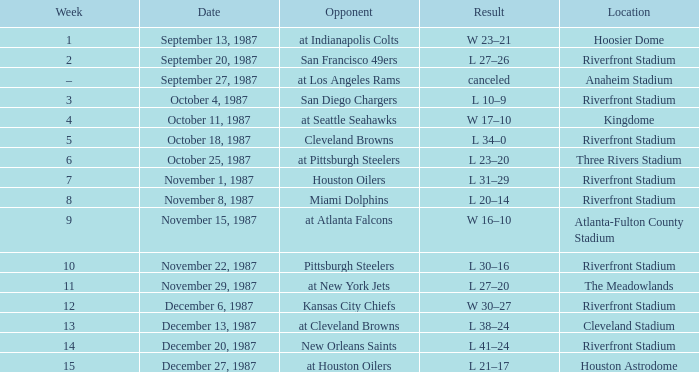What was the consequence of the game versus the miami dolphins conducted at the riverfront stadium? L 20–14. 